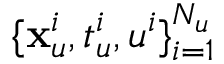Convert formula to latex. <formula><loc_0><loc_0><loc_500><loc_500>\{ x _ { u } ^ { i } , t _ { u } ^ { i } , u ^ { i } \} _ { i = 1 } ^ { N _ { u } }</formula> 